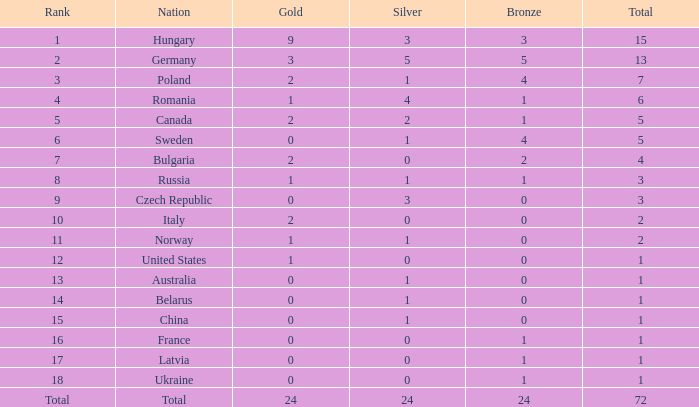What average total has 0 as the gold, with 6 as the rank? 5.0. 